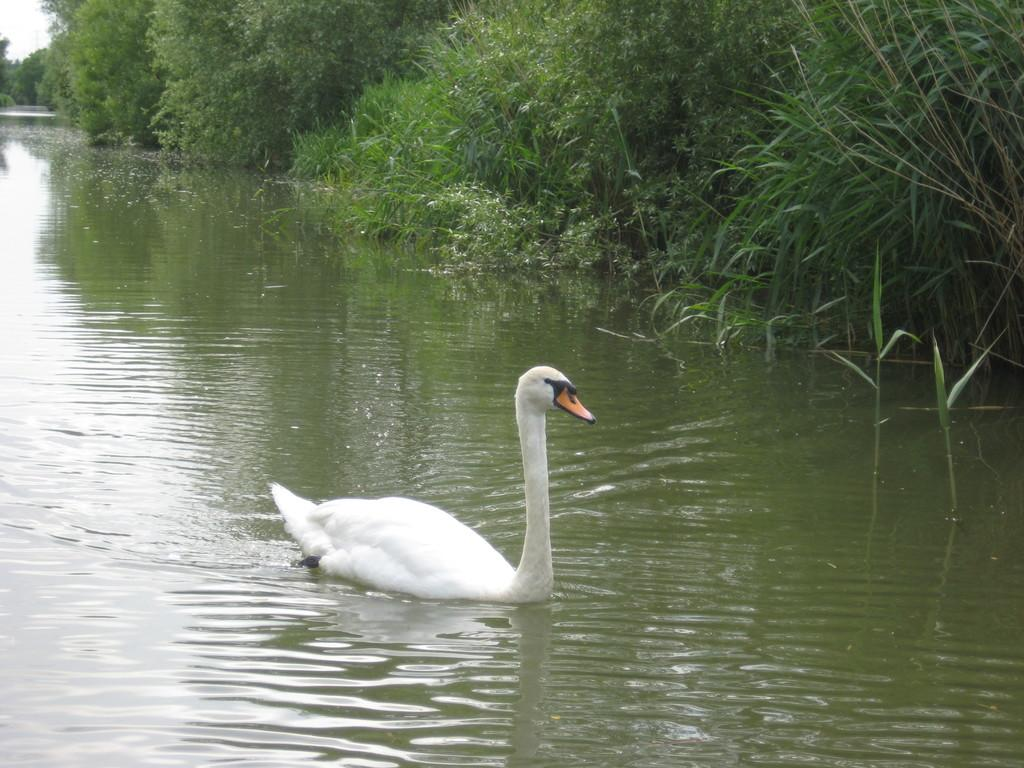What animal can be seen in the water in the image? There is a swan in the water in the image. What type of vegetation is on the right side of the image? There are plants on the right side of the image. How many apples are hanging from the jar in the image? There is no jar or apples present in the image. What type of connection can be seen between the swan and the plants in the image? There is no direct connection between the swan and the plants in the image; they are separate elements in the scene. 